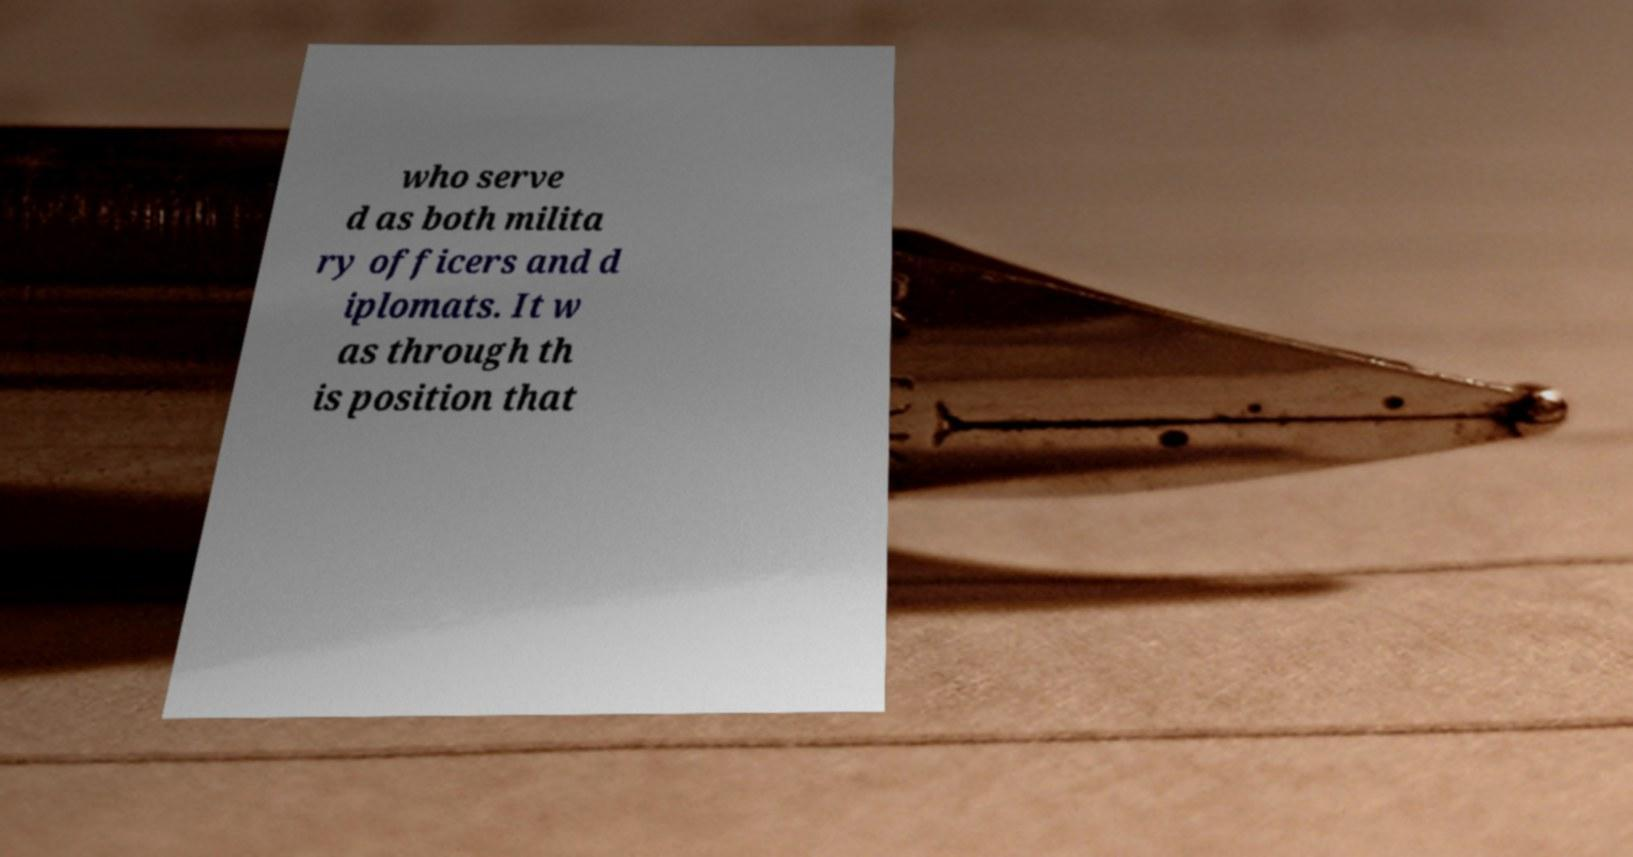What messages or text are displayed in this image? I need them in a readable, typed format. who serve d as both milita ry officers and d iplomats. It w as through th is position that 